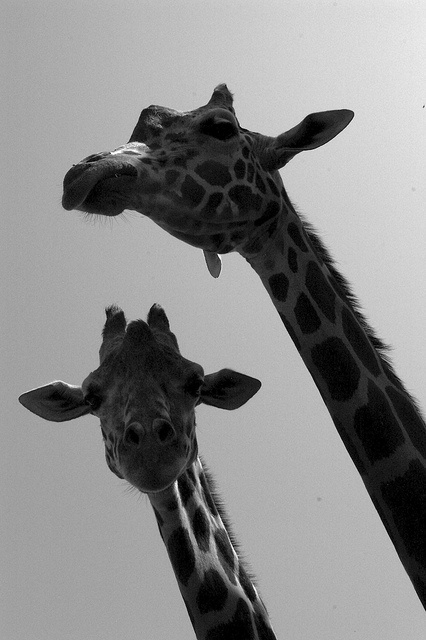Describe the objects in this image and their specific colors. I can see giraffe in darkgray, black, gray, and lightgray tones and giraffe in darkgray, black, gray, and lightgray tones in this image. 